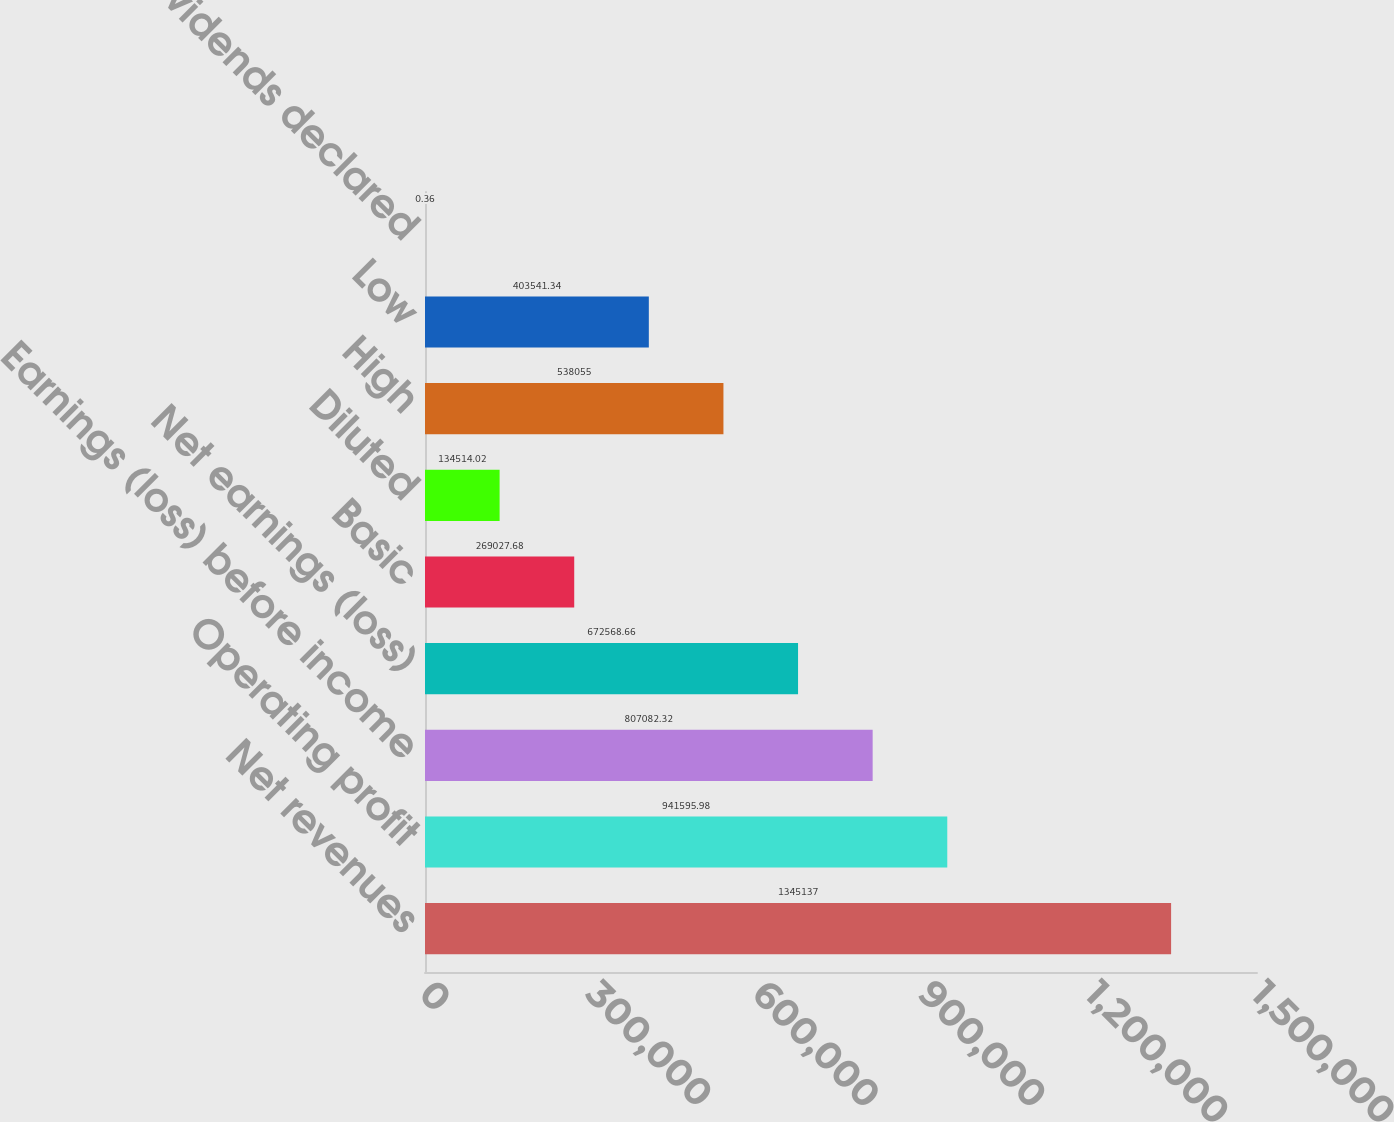<chart> <loc_0><loc_0><loc_500><loc_500><bar_chart><fcel>Net revenues<fcel>Operating profit<fcel>Earnings (loss) before income<fcel>Net earnings (loss)<fcel>Basic<fcel>Diluted<fcel>High<fcel>Low<fcel>Cash dividends declared<nl><fcel>1.34514e+06<fcel>941596<fcel>807082<fcel>672569<fcel>269028<fcel>134514<fcel>538055<fcel>403541<fcel>0.36<nl></chart> 